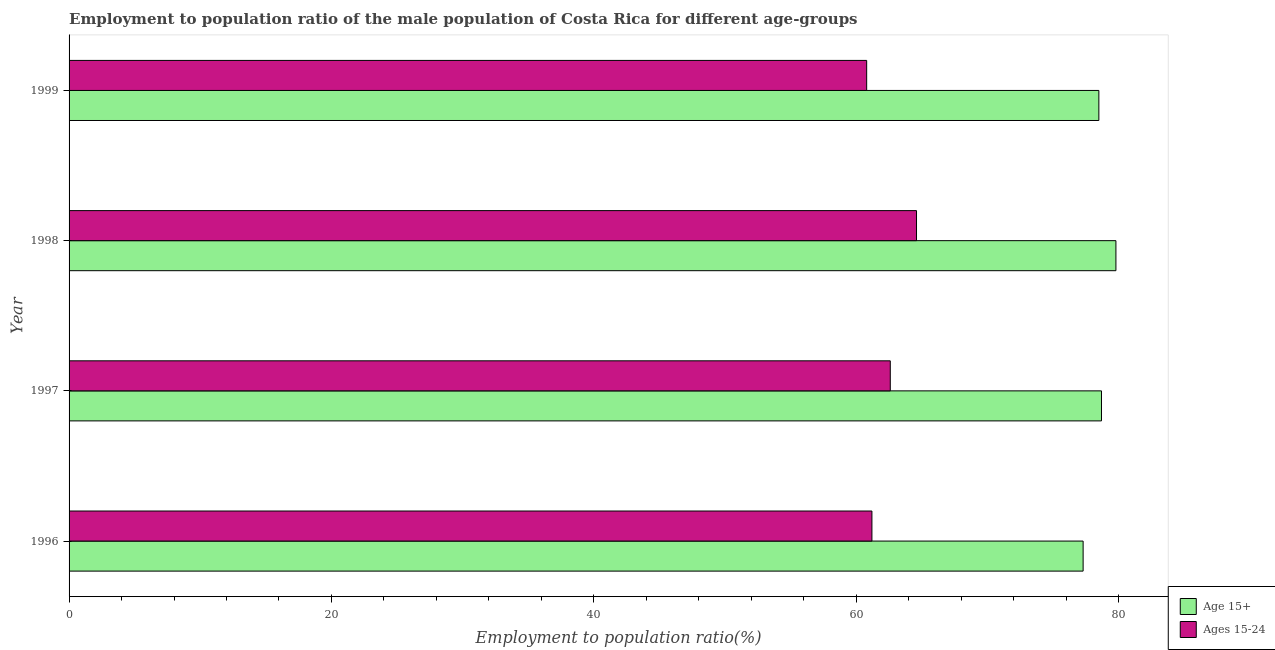How many different coloured bars are there?
Make the answer very short. 2. How many bars are there on the 3rd tick from the bottom?
Your answer should be very brief. 2. What is the label of the 2nd group of bars from the top?
Ensure brevity in your answer.  1998. What is the employment to population ratio(age 15-24) in 1996?
Offer a terse response. 61.2. Across all years, what is the maximum employment to population ratio(age 15+)?
Offer a very short reply. 79.8. Across all years, what is the minimum employment to population ratio(age 15+)?
Offer a terse response. 77.3. What is the total employment to population ratio(age 15-24) in the graph?
Ensure brevity in your answer.  249.2. What is the difference between the employment to population ratio(age 15+) in 1996 and the employment to population ratio(age 15-24) in 1999?
Your response must be concise. 16.5. What is the average employment to population ratio(age 15-24) per year?
Ensure brevity in your answer.  62.3. In how many years, is the employment to population ratio(age 15-24) greater than 60 %?
Ensure brevity in your answer.  4. Is the employment to population ratio(age 15-24) in 1996 less than that in 1997?
Provide a succinct answer. Yes. Is the difference between the employment to population ratio(age 15-24) in 1996 and 1998 greater than the difference between the employment to population ratio(age 15+) in 1996 and 1998?
Ensure brevity in your answer.  No. What is the difference between the highest and the lowest employment to population ratio(age 15-24)?
Give a very brief answer. 3.8. In how many years, is the employment to population ratio(age 15-24) greater than the average employment to population ratio(age 15-24) taken over all years?
Make the answer very short. 2. Is the sum of the employment to population ratio(age 15+) in 1998 and 1999 greater than the maximum employment to population ratio(age 15-24) across all years?
Your answer should be compact. Yes. What does the 2nd bar from the top in 1999 represents?
Your answer should be very brief. Age 15+. What does the 1st bar from the bottom in 1999 represents?
Ensure brevity in your answer.  Age 15+. How many years are there in the graph?
Make the answer very short. 4. What is the difference between two consecutive major ticks on the X-axis?
Your answer should be compact. 20. Where does the legend appear in the graph?
Offer a very short reply. Bottom right. How are the legend labels stacked?
Provide a short and direct response. Vertical. What is the title of the graph?
Give a very brief answer. Employment to population ratio of the male population of Costa Rica for different age-groups. Does "Private funds" appear as one of the legend labels in the graph?
Your response must be concise. No. What is the label or title of the X-axis?
Provide a succinct answer. Employment to population ratio(%). What is the label or title of the Y-axis?
Give a very brief answer. Year. What is the Employment to population ratio(%) of Age 15+ in 1996?
Your answer should be very brief. 77.3. What is the Employment to population ratio(%) in Ages 15-24 in 1996?
Offer a very short reply. 61.2. What is the Employment to population ratio(%) of Age 15+ in 1997?
Provide a short and direct response. 78.7. What is the Employment to population ratio(%) of Ages 15-24 in 1997?
Keep it short and to the point. 62.6. What is the Employment to population ratio(%) in Age 15+ in 1998?
Your answer should be compact. 79.8. What is the Employment to population ratio(%) of Ages 15-24 in 1998?
Your answer should be compact. 64.6. What is the Employment to population ratio(%) in Age 15+ in 1999?
Give a very brief answer. 78.5. What is the Employment to population ratio(%) of Ages 15-24 in 1999?
Your answer should be compact. 60.8. Across all years, what is the maximum Employment to population ratio(%) in Age 15+?
Provide a short and direct response. 79.8. Across all years, what is the maximum Employment to population ratio(%) of Ages 15-24?
Give a very brief answer. 64.6. Across all years, what is the minimum Employment to population ratio(%) in Age 15+?
Your response must be concise. 77.3. Across all years, what is the minimum Employment to population ratio(%) in Ages 15-24?
Your answer should be compact. 60.8. What is the total Employment to population ratio(%) in Age 15+ in the graph?
Provide a succinct answer. 314.3. What is the total Employment to population ratio(%) of Ages 15-24 in the graph?
Your response must be concise. 249.2. What is the difference between the Employment to population ratio(%) of Ages 15-24 in 1996 and that in 1997?
Keep it short and to the point. -1.4. What is the difference between the Employment to population ratio(%) in Ages 15-24 in 1996 and that in 1998?
Keep it short and to the point. -3.4. What is the difference between the Employment to population ratio(%) in Age 15+ in 1996 and that in 1999?
Provide a short and direct response. -1.2. What is the difference between the Employment to population ratio(%) of Ages 15-24 in 1997 and that in 1998?
Your response must be concise. -2. What is the difference between the Employment to population ratio(%) of Age 15+ in 1997 and that in 1999?
Offer a very short reply. 0.2. What is the difference between the Employment to population ratio(%) in Ages 15-24 in 1998 and that in 1999?
Keep it short and to the point. 3.8. What is the difference between the Employment to population ratio(%) in Age 15+ in 1996 and the Employment to population ratio(%) in Ages 15-24 in 1997?
Make the answer very short. 14.7. What is the difference between the Employment to population ratio(%) of Age 15+ in 1996 and the Employment to population ratio(%) of Ages 15-24 in 1999?
Ensure brevity in your answer.  16.5. What is the difference between the Employment to population ratio(%) of Age 15+ in 1997 and the Employment to population ratio(%) of Ages 15-24 in 1998?
Provide a succinct answer. 14.1. What is the difference between the Employment to population ratio(%) of Age 15+ in 1997 and the Employment to population ratio(%) of Ages 15-24 in 1999?
Your answer should be compact. 17.9. What is the average Employment to population ratio(%) of Age 15+ per year?
Your answer should be very brief. 78.58. What is the average Employment to population ratio(%) of Ages 15-24 per year?
Offer a terse response. 62.3. In the year 1996, what is the difference between the Employment to population ratio(%) of Age 15+ and Employment to population ratio(%) of Ages 15-24?
Provide a short and direct response. 16.1. In the year 1999, what is the difference between the Employment to population ratio(%) in Age 15+ and Employment to population ratio(%) in Ages 15-24?
Give a very brief answer. 17.7. What is the ratio of the Employment to population ratio(%) in Age 15+ in 1996 to that in 1997?
Offer a terse response. 0.98. What is the ratio of the Employment to population ratio(%) in Ages 15-24 in 1996 to that in 1997?
Your answer should be compact. 0.98. What is the ratio of the Employment to population ratio(%) of Age 15+ in 1996 to that in 1998?
Give a very brief answer. 0.97. What is the ratio of the Employment to population ratio(%) in Age 15+ in 1996 to that in 1999?
Your answer should be compact. 0.98. What is the ratio of the Employment to population ratio(%) of Ages 15-24 in 1996 to that in 1999?
Ensure brevity in your answer.  1.01. What is the ratio of the Employment to population ratio(%) of Age 15+ in 1997 to that in 1998?
Make the answer very short. 0.99. What is the ratio of the Employment to population ratio(%) of Age 15+ in 1997 to that in 1999?
Keep it short and to the point. 1. What is the ratio of the Employment to population ratio(%) in Ages 15-24 in 1997 to that in 1999?
Keep it short and to the point. 1.03. What is the ratio of the Employment to population ratio(%) in Age 15+ in 1998 to that in 1999?
Provide a succinct answer. 1.02. What is the ratio of the Employment to population ratio(%) of Ages 15-24 in 1998 to that in 1999?
Provide a succinct answer. 1.06. What is the difference between the highest and the second highest Employment to population ratio(%) of Age 15+?
Your answer should be compact. 1.1. What is the difference between the highest and the second highest Employment to population ratio(%) of Ages 15-24?
Ensure brevity in your answer.  2. What is the difference between the highest and the lowest Employment to population ratio(%) in Ages 15-24?
Ensure brevity in your answer.  3.8. 